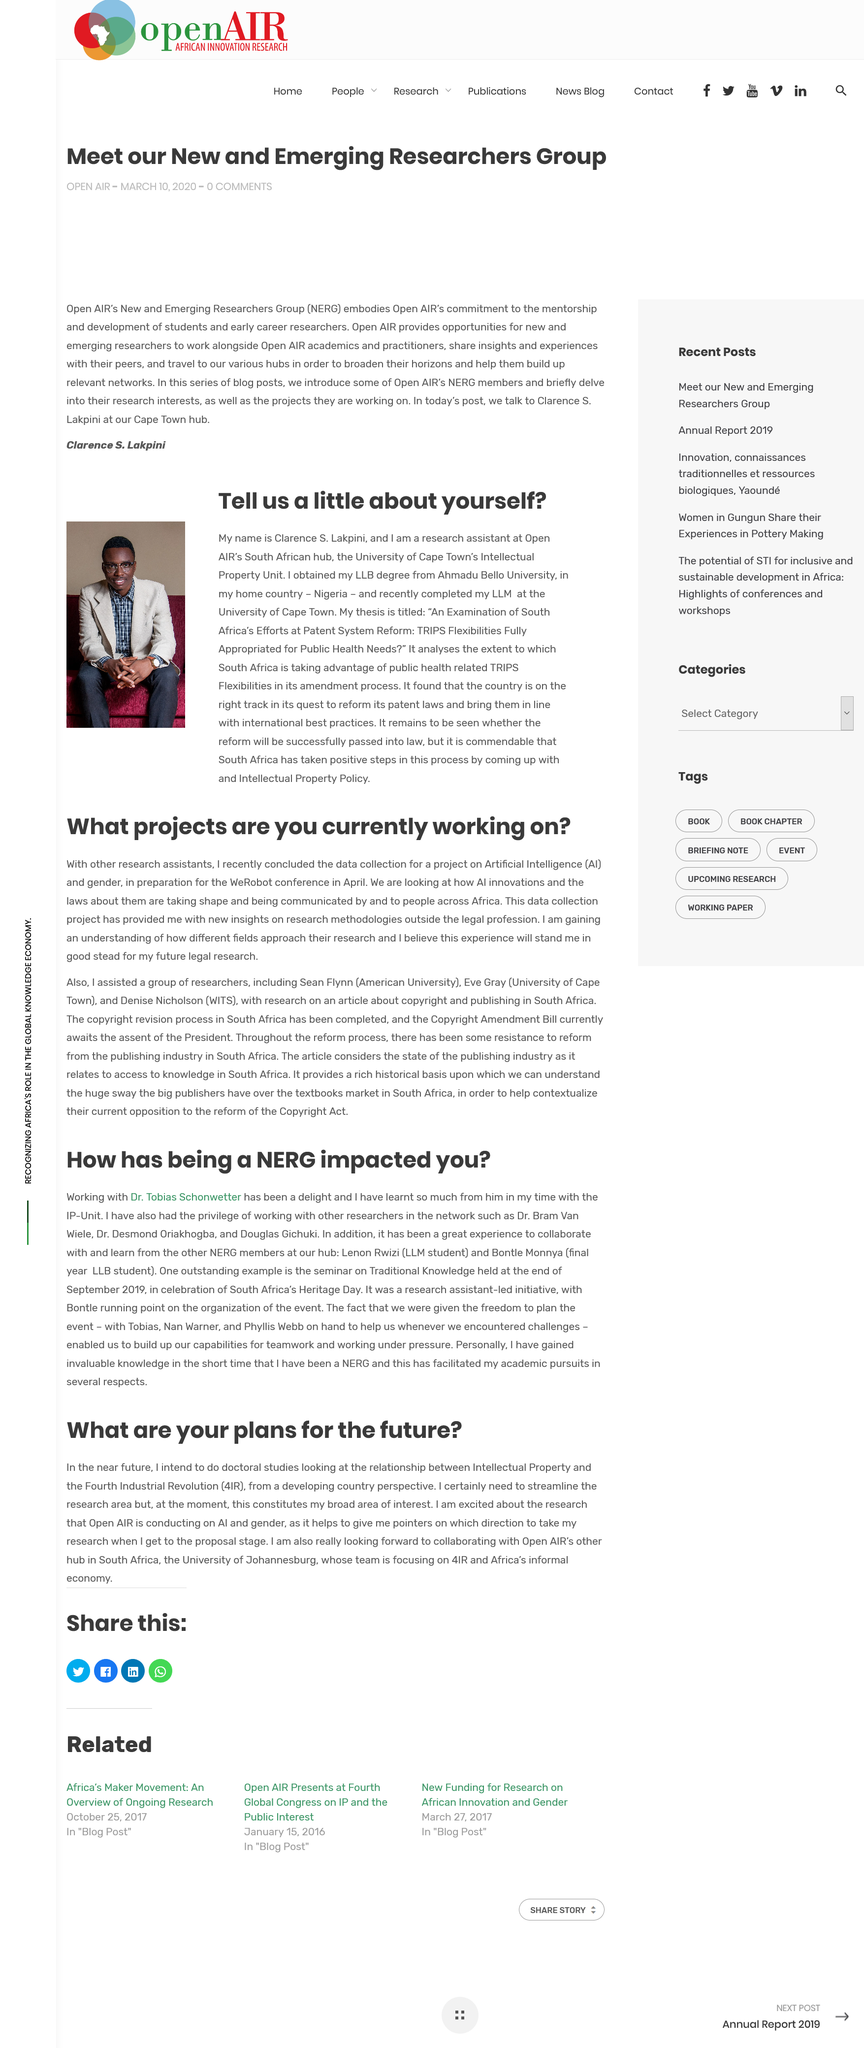Point out several critical features in this image. The person's name is Clarence S. Lakpini. The Fourth Industrial Revolution, commonly referred to as 4IR, is the latest technological advancement that has transformed the way we live, work, and communicate. It represents a new era of innovation that builds upon the foundations of the past industrial revolutions, bringing about unprecedented changes in the way we produce, distribute, and consume goods and services. The conference will be held in April, as stated in the previous response. Yes, the data collection for an Artificial Intelligence project is described in the article. New and Emerging Researchers Group (NERG) is an acronym that stands for the organization that brings together researchers from various fields and disciplines to collaborate and share ideas. 